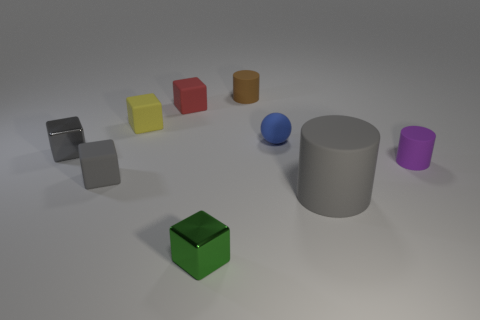How many things are large cylinders or small brown rubber cylinders?
Provide a succinct answer. 2. What is the shape of the metallic object that is behind the small cylinder that is in front of the brown rubber cylinder?
Your answer should be compact. Cube. Is the shape of the small object that is right of the tiny rubber ball the same as  the tiny green object?
Ensure brevity in your answer.  No. What size is the red object that is the same material as the tiny brown object?
Your answer should be compact. Small. What number of objects are either tiny red matte objects to the left of the tiny purple cylinder or things that are on the left side of the green metallic cube?
Provide a succinct answer. 4. Are there an equal number of gray matte objects on the right side of the tiny gray shiny cube and things that are on the left side of the yellow block?
Ensure brevity in your answer.  Yes. What is the color of the small matte thing in front of the purple thing?
Offer a terse response. Gray. Is the color of the big object the same as the small shiny object that is behind the small green thing?
Ensure brevity in your answer.  Yes. Are there fewer green things than tiny metallic objects?
Give a very brief answer. Yes. There is a metallic object left of the tiny yellow object; is it the same color as the large rubber cylinder?
Ensure brevity in your answer.  Yes. 